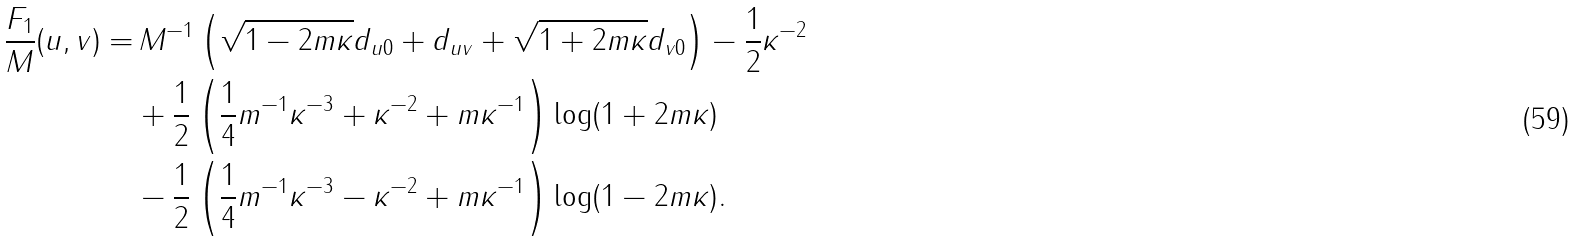<formula> <loc_0><loc_0><loc_500><loc_500>\frac { F _ { 1 } } { M } ( u , v ) = & \, M ^ { - 1 } \left ( \sqrt { 1 - 2 m \kappa } d _ { u 0 } + d _ { u v } + \sqrt { 1 + 2 m \kappa } d _ { v 0 } \right ) - \frac { 1 } { 2 } \kappa ^ { - 2 } \\ & + \frac { 1 } { 2 } \left ( \frac { 1 } { 4 } m ^ { - 1 } \kappa ^ { - 3 } + \kappa ^ { - 2 } + m \kappa ^ { - 1 } \right ) \log ( 1 + 2 m \kappa ) \\ & - \frac { 1 } { 2 } \left ( \frac { 1 } { 4 } m ^ { - 1 } \kappa ^ { - 3 } - \kappa ^ { - 2 } + m \kappa ^ { - 1 } \right ) \log ( 1 - 2 m \kappa ) .</formula> 